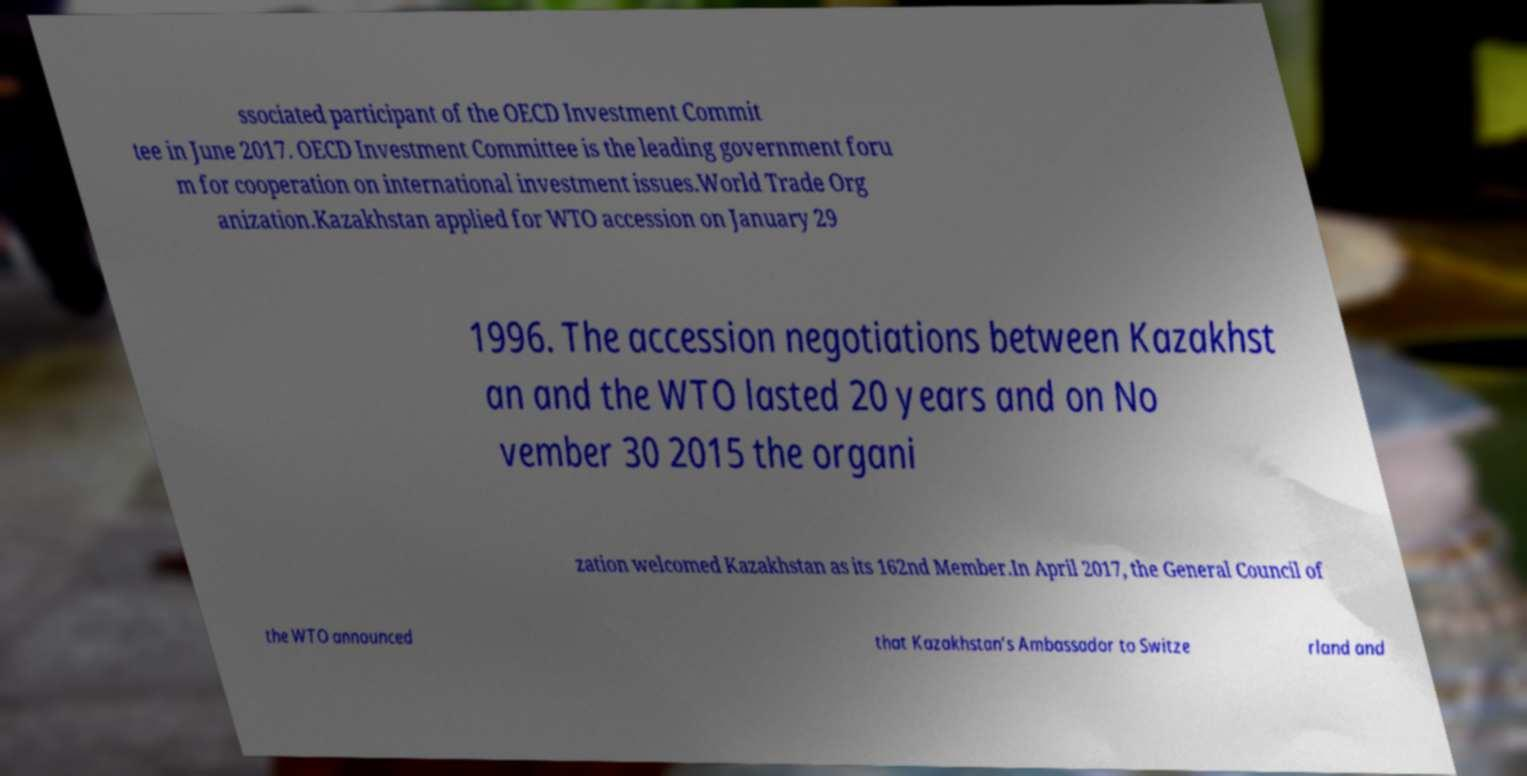Could you assist in decoding the text presented in this image and type it out clearly? ssociated participant of the OECD Investment Commit tee in June 2017. OECD Investment Committee is the leading government foru m for cooperation on international investment issues.World Trade Org anization.Kazakhstan applied for WTO accession on January 29 1996. The accession negotiations between Kazakhst an and the WTO lasted 20 years and on No vember 30 2015 the organi zation welcomed Kazakhstan as its 162nd Member.In April 2017, the General Council of the WTO announced that Kazakhstan’s Ambassador to Switze rland and 